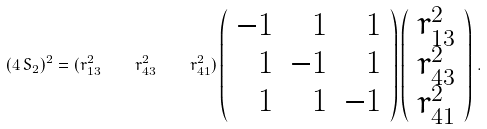<formula> <loc_0><loc_0><loc_500><loc_500>( 4 \, S _ { 2 } ) ^ { 2 } = ( r _ { 1 3 } ^ { 2 } \quad r _ { 4 3 } ^ { 2 } \quad r _ { 4 1 } ^ { 2 } ) \left ( \begin{array} { r r r } - 1 & 1 & 1 \\ 1 & - 1 & 1 \\ 1 & 1 & - 1 \end{array} \right ) \left ( \begin{array} { c } r _ { 1 3 } ^ { 2 } \\ r _ { 4 3 } ^ { 2 } \\ r _ { 4 1 } ^ { 2 } \end{array} \right ) \, .</formula> 